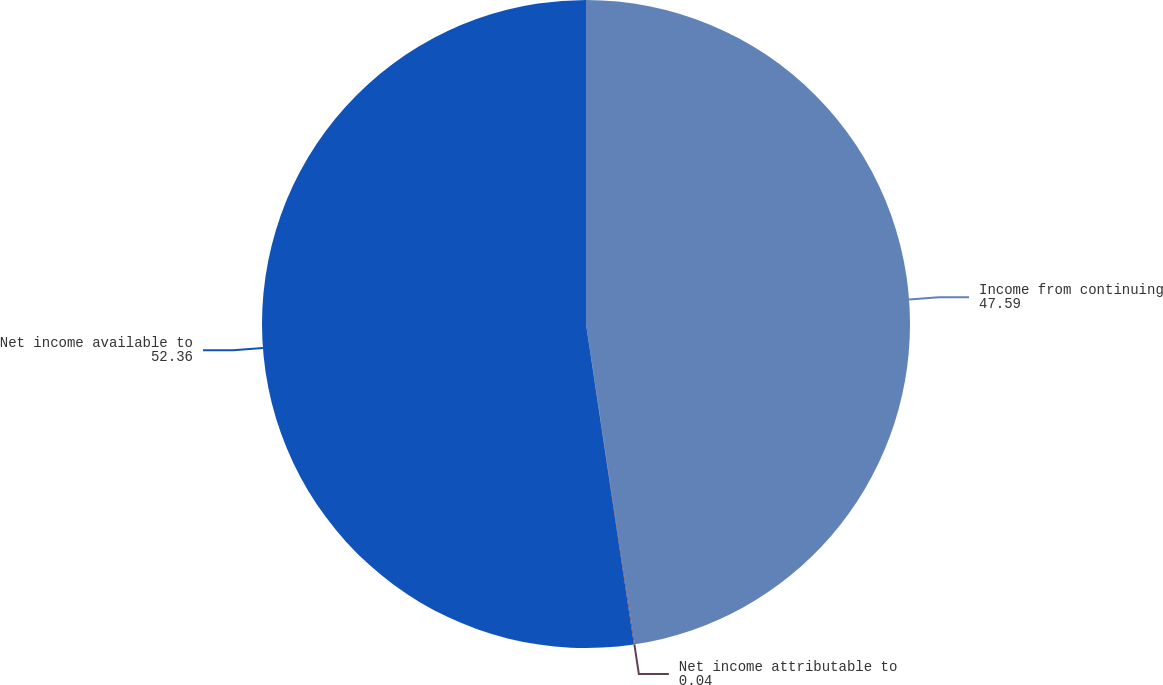Convert chart. <chart><loc_0><loc_0><loc_500><loc_500><pie_chart><fcel>Income from continuing<fcel>Net income attributable to<fcel>Net income available to<nl><fcel>47.59%<fcel>0.04%<fcel>52.36%<nl></chart> 